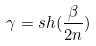Convert formula to latex. <formula><loc_0><loc_0><loc_500><loc_500>\gamma = s h ( \frac { \beta } { 2 n } )</formula> 